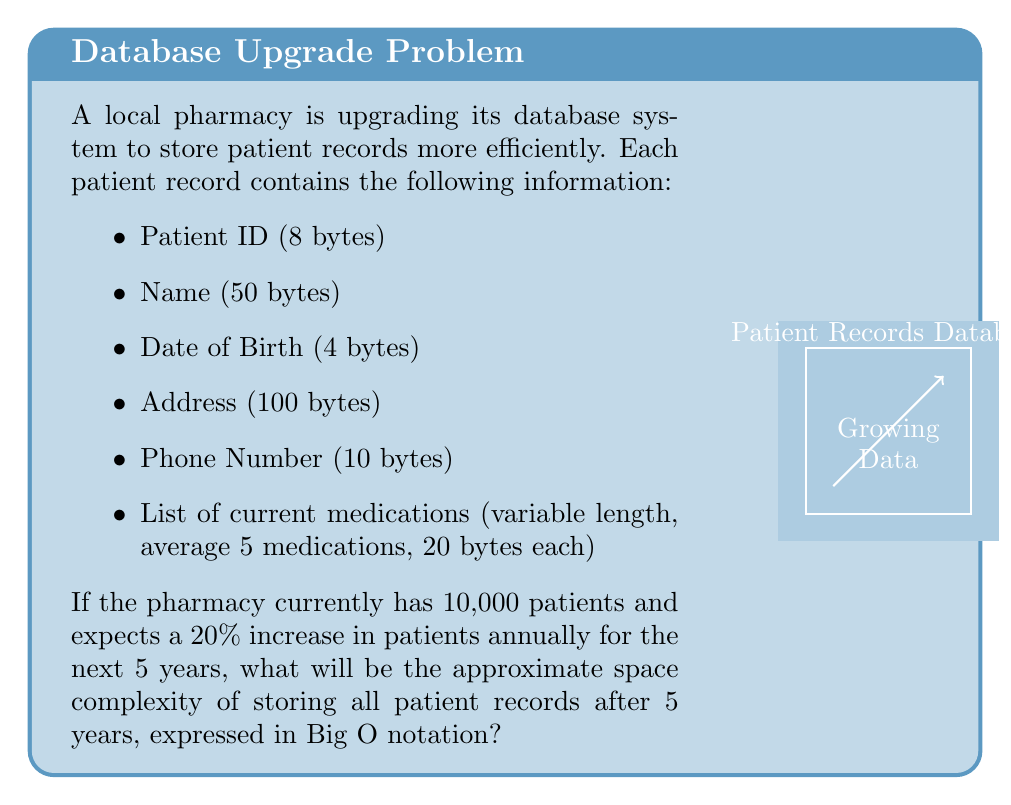Could you help me with this problem? Let's approach this step-by-step:

1) First, calculate the size of a single patient record:
   $8 + 50 + 4 + 100 + 10 + (5 * 20) = 272$ bytes

2) The number of patients after 5 years with a 20% annual increase:
   $10,000 * (1.2)^5 \approx 24,883$ patients

3) Total space needed after 5 years:
   $24,883 * 272 \approx 6,768,176$ bytes

4) In terms of space complexity, we're interested in how the space requirements grow with respect to the input size (number of patients). 

5) The space used is directly proportional to the number of patients. As the number of patients increases linearly, the space required also increases linearly.

6) In Big O notation, we express this as $O(n)$, where $n$ is the number of patients.

7) The constant factors (like the size of each record) and the exact number of patients don't affect the Big O notation, as we're concerned with the growth pattern, not the exact values.

Therefore, the space complexity is $O(n)$, indicating linear space complexity with respect to the number of patients.
Answer: $O(n)$ 